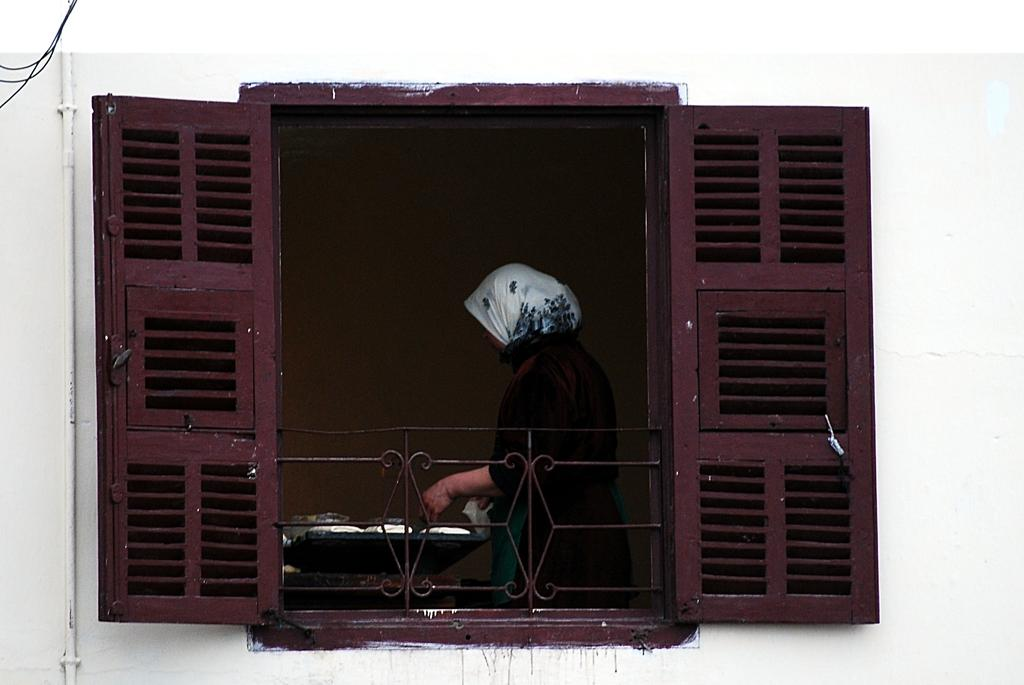What type of structure is visible in the image? There is a building in the image. Can you describe any specific features of the building? There is a window in the building. What is the color of the window? The window is brown in color. What is happening inside the building? There is a woman in the window, and she appears to be cooking. Is there a bag of quicksand visible in the image? No, there is no bag of quicksand present in the image. 